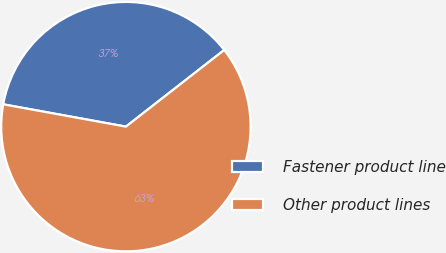Convert chart. <chart><loc_0><loc_0><loc_500><loc_500><pie_chart><fcel>Fastener product line<fcel>Other product lines<nl><fcel>36.6%<fcel>63.4%<nl></chart> 